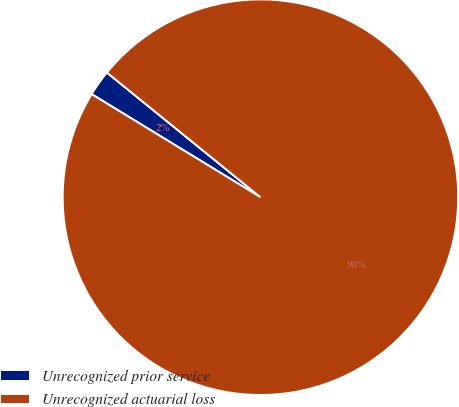Convert chart to OTSL. <chart><loc_0><loc_0><loc_500><loc_500><pie_chart><fcel>Unrecognized prior service<fcel>Unrecognized actuarial loss<nl><fcel>2.13%<fcel>97.87%<nl></chart> 